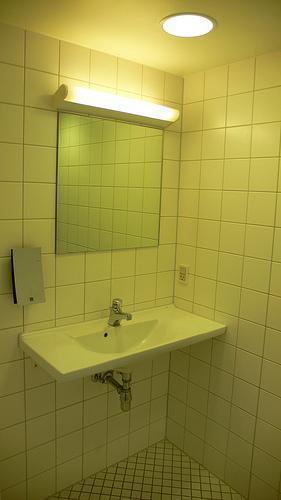How many faucets can be seen?
Give a very brief answer. 1. 